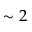Convert formula to latex. <formula><loc_0><loc_0><loc_500><loc_500>\sim 2</formula> 